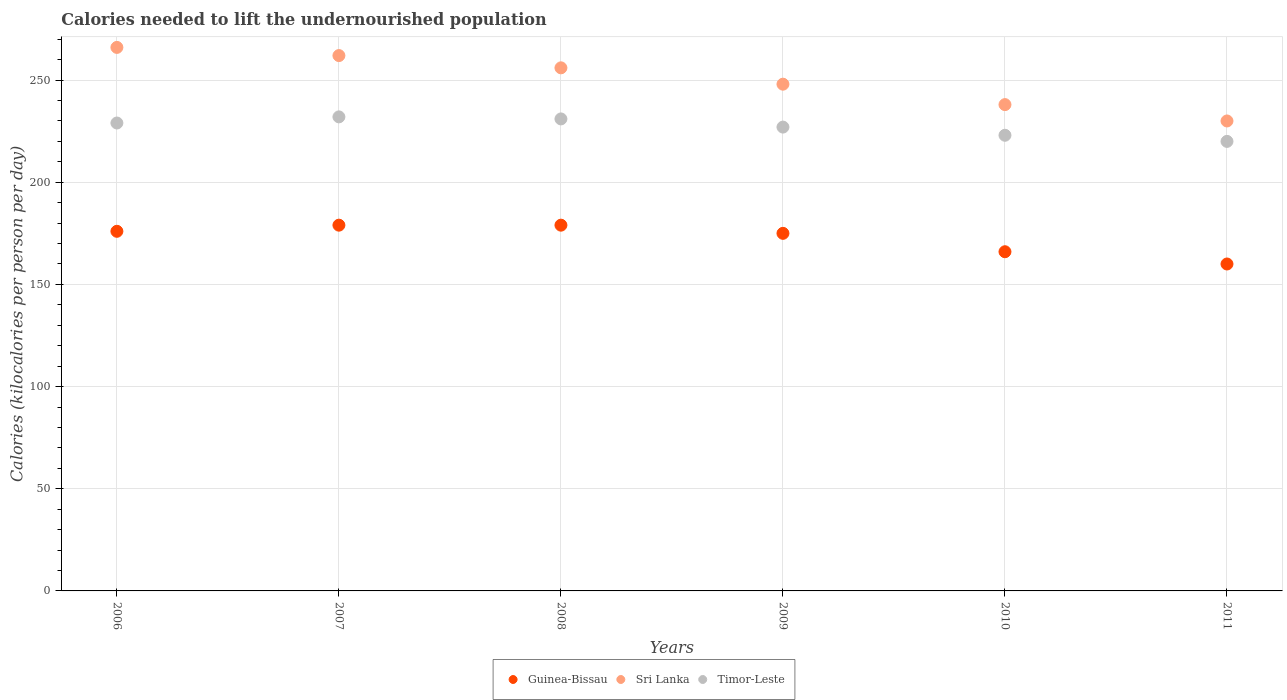How many different coloured dotlines are there?
Ensure brevity in your answer.  3. Is the number of dotlines equal to the number of legend labels?
Provide a succinct answer. Yes. What is the total calories needed to lift the undernourished population in Sri Lanka in 2006?
Provide a short and direct response. 266. Across all years, what is the maximum total calories needed to lift the undernourished population in Timor-Leste?
Your answer should be very brief. 232. Across all years, what is the minimum total calories needed to lift the undernourished population in Sri Lanka?
Give a very brief answer. 230. In which year was the total calories needed to lift the undernourished population in Timor-Leste minimum?
Ensure brevity in your answer.  2011. What is the total total calories needed to lift the undernourished population in Guinea-Bissau in the graph?
Your answer should be very brief. 1035. What is the difference between the total calories needed to lift the undernourished population in Guinea-Bissau in 2007 and the total calories needed to lift the undernourished population in Sri Lanka in 2008?
Your answer should be very brief. -77. What is the average total calories needed to lift the undernourished population in Sri Lanka per year?
Offer a terse response. 250. In the year 2006, what is the difference between the total calories needed to lift the undernourished population in Guinea-Bissau and total calories needed to lift the undernourished population in Timor-Leste?
Give a very brief answer. -53. In how many years, is the total calories needed to lift the undernourished population in Timor-Leste greater than 190 kilocalories?
Offer a terse response. 6. What is the ratio of the total calories needed to lift the undernourished population in Guinea-Bissau in 2008 to that in 2011?
Provide a succinct answer. 1.12. Is the total calories needed to lift the undernourished population in Timor-Leste in 2010 less than that in 2011?
Provide a succinct answer. No. Is the difference between the total calories needed to lift the undernourished population in Guinea-Bissau in 2007 and 2011 greater than the difference between the total calories needed to lift the undernourished population in Timor-Leste in 2007 and 2011?
Offer a very short reply. Yes. What is the difference between the highest and the second highest total calories needed to lift the undernourished population in Guinea-Bissau?
Give a very brief answer. 0. What is the difference between the highest and the lowest total calories needed to lift the undernourished population in Sri Lanka?
Give a very brief answer. 36. In how many years, is the total calories needed to lift the undernourished population in Sri Lanka greater than the average total calories needed to lift the undernourished population in Sri Lanka taken over all years?
Offer a terse response. 3. Is the sum of the total calories needed to lift the undernourished population in Sri Lanka in 2008 and 2010 greater than the maximum total calories needed to lift the undernourished population in Guinea-Bissau across all years?
Offer a very short reply. Yes. Does the total calories needed to lift the undernourished population in Timor-Leste monotonically increase over the years?
Offer a terse response. No. How many dotlines are there?
Your answer should be very brief. 3. How many years are there in the graph?
Ensure brevity in your answer.  6. What is the difference between two consecutive major ticks on the Y-axis?
Your response must be concise. 50. Does the graph contain grids?
Give a very brief answer. Yes. Where does the legend appear in the graph?
Ensure brevity in your answer.  Bottom center. How are the legend labels stacked?
Your response must be concise. Horizontal. What is the title of the graph?
Give a very brief answer. Calories needed to lift the undernourished population. Does "Estonia" appear as one of the legend labels in the graph?
Give a very brief answer. No. What is the label or title of the Y-axis?
Give a very brief answer. Calories (kilocalories per person per day). What is the Calories (kilocalories per person per day) in Guinea-Bissau in 2006?
Provide a succinct answer. 176. What is the Calories (kilocalories per person per day) of Sri Lanka in 2006?
Provide a succinct answer. 266. What is the Calories (kilocalories per person per day) in Timor-Leste in 2006?
Give a very brief answer. 229. What is the Calories (kilocalories per person per day) in Guinea-Bissau in 2007?
Offer a terse response. 179. What is the Calories (kilocalories per person per day) of Sri Lanka in 2007?
Offer a very short reply. 262. What is the Calories (kilocalories per person per day) of Timor-Leste in 2007?
Provide a succinct answer. 232. What is the Calories (kilocalories per person per day) in Guinea-Bissau in 2008?
Offer a very short reply. 179. What is the Calories (kilocalories per person per day) of Sri Lanka in 2008?
Your answer should be compact. 256. What is the Calories (kilocalories per person per day) in Timor-Leste in 2008?
Offer a terse response. 231. What is the Calories (kilocalories per person per day) in Guinea-Bissau in 2009?
Give a very brief answer. 175. What is the Calories (kilocalories per person per day) of Sri Lanka in 2009?
Your answer should be compact. 248. What is the Calories (kilocalories per person per day) in Timor-Leste in 2009?
Provide a short and direct response. 227. What is the Calories (kilocalories per person per day) in Guinea-Bissau in 2010?
Keep it short and to the point. 166. What is the Calories (kilocalories per person per day) in Sri Lanka in 2010?
Keep it short and to the point. 238. What is the Calories (kilocalories per person per day) in Timor-Leste in 2010?
Keep it short and to the point. 223. What is the Calories (kilocalories per person per day) in Guinea-Bissau in 2011?
Provide a short and direct response. 160. What is the Calories (kilocalories per person per day) of Sri Lanka in 2011?
Your answer should be very brief. 230. What is the Calories (kilocalories per person per day) in Timor-Leste in 2011?
Your answer should be compact. 220. Across all years, what is the maximum Calories (kilocalories per person per day) in Guinea-Bissau?
Provide a short and direct response. 179. Across all years, what is the maximum Calories (kilocalories per person per day) of Sri Lanka?
Your answer should be compact. 266. Across all years, what is the maximum Calories (kilocalories per person per day) in Timor-Leste?
Keep it short and to the point. 232. Across all years, what is the minimum Calories (kilocalories per person per day) in Guinea-Bissau?
Ensure brevity in your answer.  160. Across all years, what is the minimum Calories (kilocalories per person per day) in Sri Lanka?
Provide a succinct answer. 230. Across all years, what is the minimum Calories (kilocalories per person per day) of Timor-Leste?
Keep it short and to the point. 220. What is the total Calories (kilocalories per person per day) of Guinea-Bissau in the graph?
Give a very brief answer. 1035. What is the total Calories (kilocalories per person per day) in Sri Lanka in the graph?
Your response must be concise. 1500. What is the total Calories (kilocalories per person per day) of Timor-Leste in the graph?
Offer a terse response. 1362. What is the difference between the Calories (kilocalories per person per day) of Guinea-Bissau in 2006 and that in 2007?
Make the answer very short. -3. What is the difference between the Calories (kilocalories per person per day) in Sri Lanka in 2006 and that in 2009?
Offer a terse response. 18. What is the difference between the Calories (kilocalories per person per day) of Timor-Leste in 2006 and that in 2009?
Provide a succinct answer. 2. What is the difference between the Calories (kilocalories per person per day) of Timor-Leste in 2006 and that in 2010?
Provide a succinct answer. 6. What is the difference between the Calories (kilocalories per person per day) in Guinea-Bissau in 2006 and that in 2011?
Keep it short and to the point. 16. What is the difference between the Calories (kilocalories per person per day) of Guinea-Bissau in 2007 and that in 2008?
Make the answer very short. 0. What is the difference between the Calories (kilocalories per person per day) in Guinea-Bissau in 2007 and that in 2009?
Your answer should be very brief. 4. What is the difference between the Calories (kilocalories per person per day) of Sri Lanka in 2007 and that in 2009?
Offer a very short reply. 14. What is the difference between the Calories (kilocalories per person per day) of Timor-Leste in 2007 and that in 2009?
Your answer should be compact. 5. What is the difference between the Calories (kilocalories per person per day) of Timor-Leste in 2007 and that in 2010?
Give a very brief answer. 9. What is the difference between the Calories (kilocalories per person per day) of Sri Lanka in 2007 and that in 2011?
Give a very brief answer. 32. What is the difference between the Calories (kilocalories per person per day) in Timor-Leste in 2008 and that in 2009?
Provide a succinct answer. 4. What is the difference between the Calories (kilocalories per person per day) of Guinea-Bissau in 2009 and that in 2010?
Your response must be concise. 9. What is the difference between the Calories (kilocalories per person per day) of Timor-Leste in 2009 and that in 2010?
Ensure brevity in your answer.  4. What is the difference between the Calories (kilocalories per person per day) in Guinea-Bissau in 2009 and that in 2011?
Make the answer very short. 15. What is the difference between the Calories (kilocalories per person per day) in Sri Lanka in 2009 and that in 2011?
Your response must be concise. 18. What is the difference between the Calories (kilocalories per person per day) in Timor-Leste in 2009 and that in 2011?
Offer a terse response. 7. What is the difference between the Calories (kilocalories per person per day) in Timor-Leste in 2010 and that in 2011?
Provide a short and direct response. 3. What is the difference between the Calories (kilocalories per person per day) of Guinea-Bissau in 2006 and the Calories (kilocalories per person per day) of Sri Lanka in 2007?
Offer a terse response. -86. What is the difference between the Calories (kilocalories per person per day) in Guinea-Bissau in 2006 and the Calories (kilocalories per person per day) in Timor-Leste in 2007?
Provide a succinct answer. -56. What is the difference between the Calories (kilocalories per person per day) in Sri Lanka in 2006 and the Calories (kilocalories per person per day) in Timor-Leste in 2007?
Give a very brief answer. 34. What is the difference between the Calories (kilocalories per person per day) of Guinea-Bissau in 2006 and the Calories (kilocalories per person per day) of Sri Lanka in 2008?
Your response must be concise. -80. What is the difference between the Calories (kilocalories per person per day) in Guinea-Bissau in 2006 and the Calories (kilocalories per person per day) in Timor-Leste in 2008?
Make the answer very short. -55. What is the difference between the Calories (kilocalories per person per day) in Guinea-Bissau in 2006 and the Calories (kilocalories per person per day) in Sri Lanka in 2009?
Make the answer very short. -72. What is the difference between the Calories (kilocalories per person per day) in Guinea-Bissau in 2006 and the Calories (kilocalories per person per day) in Timor-Leste in 2009?
Keep it short and to the point. -51. What is the difference between the Calories (kilocalories per person per day) in Sri Lanka in 2006 and the Calories (kilocalories per person per day) in Timor-Leste in 2009?
Offer a terse response. 39. What is the difference between the Calories (kilocalories per person per day) of Guinea-Bissau in 2006 and the Calories (kilocalories per person per day) of Sri Lanka in 2010?
Your response must be concise. -62. What is the difference between the Calories (kilocalories per person per day) in Guinea-Bissau in 2006 and the Calories (kilocalories per person per day) in Timor-Leste in 2010?
Keep it short and to the point. -47. What is the difference between the Calories (kilocalories per person per day) of Sri Lanka in 2006 and the Calories (kilocalories per person per day) of Timor-Leste in 2010?
Offer a terse response. 43. What is the difference between the Calories (kilocalories per person per day) in Guinea-Bissau in 2006 and the Calories (kilocalories per person per day) in Sri Lanka in 2011?
Your answer should be very brief. -54. What is the difference between the Calories (kilocalories per person per day) of Guinea-Bissau in 2006 and the Calories (kilocalories per person per day) of Timor-Leste in 2011?
Ensure brevity in your answer.  -44. What is the difference between the Calories (kilocalories per person per day) in Sri Lanka in 2006 and the Calories (kilocalories per person per day) in Timor-Leste in 2011?
Your answer should be very brief. 46. What is the difference between the Calories (kilocalories per person per day) in Guinea-Bissau in 2007 and the Calories (kilocalories per person per day) in Sri Lanka in 2008?
Offer a very short reply. -77. What is the difference between the Calories (kilocalories per person per day) of Guinea-Bissau in 2007 and the Calories (kilocalories per person per day) of Timor-Leste in 2008?
Your response must be concise. -52. What is the difference between the Calories (kilocalories per person per day) of Sri Lanka in 2007 and the Calories (kilocalories per person per day) of Timor-Leste in 2008?
Give a very brief answer. 31. What is the difference between the Calories (kilocalories per person per day) in Guinea-Bissau in 2007 and the Calories (kilocalories per person per day) in Sri Lanka in 2009?
Offer a terse response. -69. What is the difference between the Calories (kilocalories per person per day) of Guinea-Bissau in 2007 and the Calories (kilocalories per person per day) of Timor-Leste in 2009?
Provide a short and direct response. -48. What is the difference between the Calories (kilocalories per person per day) of Guinea-Bissau in 2007 and the Calories (kilocalories per person per day) of Sri Lanka in 2010?
Offer a terse response. -59. What is the difference between the Calories (kilocalories per person per day) in Guinea-Bissau in 2007 and the Calories (kilocalories per person per day) in Timor-Leste in 2010?
Offer a very short reply. -44. What is the difference between the Calories (kilocalories per person per day) of Guinea-Bissau in 2007 and the Calories (kilocalories per person per day) of Sri Lanka in 2011?
Offer a terse response. -51. What is the difference between the Calories (kilocalories per person per day) of Guinea-Bissau in 2007 and the Calories (kilocalories per person per day) of Timor-Leste in 2011?
Keep it short and to the point. -41. What is the difference between the Calories (kilocalories per person per day) in Sri Lanka in 2007 and the Calories (kilocalories per person per day) in Timor-Leste in 2011?
Your response must be concise. 42. What is the difference between the Calories (kilocalories per person per day) in Guinea-Bissau in 2008 and the Calories (kilocalories per person per day) in Sri Lanka in 2009?
Give a very brief answer. -69. What is the difference between the Calories (kilocalories per person per day) in Guinea-Bissau in 2008 and the Calories (kilocalories per person per day) in Timor-Leste in 2009?
Offer a very short reply. -48. What is the difference between the Calories (kilocalories per person per day) in Guinea-Bissau in 2008 and the Calories (kilocalories per person per day) in Sri Lanka in 2010?
Your answer should be compact. -59. What is the difference between the Calories (kilocalories per person per day) in Guinea-Bissau in 2008 and the Calories (kilocalories per person per day) in Timor-Leste in 2010?
Offer a very short reply. -44. What is the difference between the Calories (kilocalories per person per day) in Sri Lanka in 2008 and the Calories (kilocalories per person per day) in Timor-Leste in 2010?
Give a very brief answer. 33. What is the difference between the Calories (kilocalories per person per day) of Guinea-Bissau in 2008 and the Calories (kilocalories per person per day) of Sri Lanka in 2011?
Your answer should be compact. -51. What is the difference between the Calories (kilocalories per person per day) in Guinea-Bissau in 2008 and the Calories (kilocalories per person per day) in Timor-Leste in 2011?
Give a very brief answer. -41. What is the difference between the Calories (kilocalories per person per day) of Guinea-Bissau in 2009 and the Calories (kilocalories per person per day) of Sri Lanka in 2010?
Give a very brief answer. -63. What is the difference between the Calories (kilocalories per person per day) of Guinea-Bissau in 2009 and the Calories (kilocalories per person per day) of Timor-Leste in 2010?
Give a very brief answer. -48. What is the difference between the Calories (kilocalories per person per day) in Guinea-Bissau in 2009 and the Calories (kilocalories per person per day) in Sri Lanka in 2011?
Offer a terse response. -55. What is the difference between the Calories (kilocalories per person per day) in Guinea-Bissau in 2009 and the Calories (kilocalories per person per day) in Timor-Leste in 2011?
Provide a succinct answer. -45. What is the difference between the Calories (kilocalories per person per day) in Guinea-Bissau in 2010 and the Calories (kilocalories per person per day) in Sri Lanka in 2011?
Your answer should be compact. -64. What is the difference between the Calories (kilocalories per person per day) of Guinea-Bissau in 2010 and the Calories (kilocalories per person per day) of Timor-Leste in 2011?
Offer a very short reply. -54. What is the average Calories (kilocalories per person per day) of Guinea-Bissau per year?
Provide a short and direct response. 172.5. What is the average Calories (kilocalories per person per day) in Sri Lanka per year?
Keep it short and to the point. 250. What is the average Calories (kilocalories per person per day) of Timor-Leste per year?
Provide a short and direct response. 227. In the year 2006, what is the difference between the Calories (kilocalories per person per day) of Guinea-Bissau and Calories (kilocalories per person per day) of Sri Lanka?
Keep it short and to the point. -90. In the year 2006, what is the difference between the Calories (kilocalories per person per day) in Guinea-Bissau and Calories (kilocalories per person per day) in Timor-Leste?
Ensure brevity in your answer.  -53. In the year 2006, what is the difference between the Calories (kilocalories per person per day) of Sri Lanka and Calories (kilocalories per person per day) of Timor-Leste?
Provide a succinct answer. 37. In the year 2007, what is the difference between the Calories (kilocalories per person per day) in Guinea-Bissau and Calories (kilocalories per person per day) in Sri Lanka?
Provide a succinct answer. -83. In the year 2007, what is the difference between the Calories (kilocalories per person per day) of Guinea-Bissau and Calories (kilocalories per person per day) of Timor-Leste?
Offer a very short reply. -53. In the year 2008, what is the difference between the Calories (kilocalories per person per day) of Guinea-Bissau and Calories (kilocalories per person per day) of Sri Lanka?
Make the answer very short. -77. In the year 2008, what is the difference between the Calories (kilocalories per person per day) in Guinea-Bissau and Calories (kilocalories per person per day) in Timor-Leste?
Ensure brevity in your answer.  -52. In the year 2009, what is the difference between the Calories (kilocalories per person per day) in Guinea-Bissau and Calories (kilocalories per person per day) in Sri Lanka?
Keep it short and to the point. -73. In the year 2009, what is the difference between the Calories (kilocalories per person per day) in Guinea-Bissau and Calories (kilocalories per person per day) in Timor-Leste?
Provide a succinct answer. -52. In the year 2010, what is the difference between the Calories (kilocalories per person per day) of Guinea-Bissau and Calories (kilocalories per person per day) of Sri Lanka?
Your answer should be very brief. -72. In the year 2010, what is the difference between the Calories (kilocalories per person per day) in Guinea-Bissau and Calories (kilocalories per person per day) in Timor-Leste?
Give a very brief answer. -57. In the year 2011, what is the difference between the Calories (kilocalories per person per day) in Guinea-Bissau and Calories (kilocalories per person per day) in Sri Lanka?
Your response must be concise. -70. In the year 2011, what is the difference between the Calories (kilocalories per person per day) of Guinea-Bissau and Calories (kilocalories per person per day) of Timor-Leste?
Make the answer very short. -60. In the year 2011, what is the difference between the Calories (kilocalories per person per day) of Sri Lanka and Calories (kilocalories per person per day) of Timor-Leste?
Offer a terse response. 10. What is the ratio of the Calories (kilocalories per person per day) of Guinea-Bissau in 2006 to that in 2007?
Your answer should be very brief. 0.98. What is the ratio of the Calories (kilocalories per person per day) in Sri Lanka in 2006 to that in 2007?
Make the answer very short. 1.02. What is the ratio of the Calories (kilocalories per person per day) of Timor-Leste in 2006 to that in 2007?
Make the answer very short. 0.99. What is the ratio of the Calories (kilocalories per person per day) of Guinea-Bissau in 2006 to that in 2008?
Give a very brief answer. 0.98. What is the ratio of the Calories (kilocalories per person per day) of Sri Lanka in 2006 to that in 2008?
Your response must be concise. 1.04. What is the ratio of the Calories (kilocalories per person per day) in Timor-Leste in 2006 to that in 2008?
Make the answer very short. 0.99. What is the ratio of the Calories (kilocalories per person per day) in Sri Lanka in 2006 to that in 2009?
Your response must be concise. 1.07. What is the ratio of the Calories (kilocalories per person per day) of Timor-Leste in 2006 to that in 2009?
Offer a very short reply. 1.01. What is the ratio of the Calories (kilocalories per person per day) in Guinea-Bissau in 2006 to that in 2010?
Ensure brevity in your answer.  1.06. What is the ratio of the Calories (kilocalories per person per day) of Sri Lanka in 2006 to that in 2010?
Your answer should be very brief. 1.12. What is the ratio of the Calories (kilocalories per person per day) of Timor-Leste in 2006 to that in 2010?
Keep it short and to the point. 1.03. What is the ratio of the Calories (kilocalories per person per day) in Guinea-Bissau in 2006 to that in 2011?
Your answer should be compact. 1.1. What is the ratio of the Calories (kilocalories per person per day) of Sri Lanka in 2006 to that in 2011?
Your answer should be compact. 1.16. What is the ratio of the Calories (kilocalories per person per day) in Timor-Leste in 2006 to that in 2011?
Provide a succinct answer. 1.04. What is the ratio of the Calories (kilocalories per person per day) of Guinea-Bissau in 2007 to that in 2008?
Your response must be concise. 1. What is the ratio of the Calories (kilocalories per person per day) of Sri Lanka in 2007 to that in 2008?
Your answer should be very brief. 1.02. What is the ratio of the Calories (kilocalories per person per day) of Guinea-Bissau in 2007 to that in 2009?
Provide a succinct answer. 1.02. What is the ratio of the Calories (kilocalories per person per day) in Sri Lanka in 2007 to that in 2009?
Your answer should be very brief. 1.06. What is the ratio of the Calories (kilocalories per person per day) in Timor-Leste in 2007 to that in 2009?
Offer a terse response. 1.02. What is the ratio of the Calories (kilocalories per person per day) in Guinea-Bissau in 2007 to that in 2010?
Your response must be concise. 1.08. What is the ratio of the Calories (kilocalories per person per day) in Sri Lanka in 2007 to that in 2010?
Offer a terse response. 1.1. What is the ratio of the Calories (kilocalories per person per day) in Timor-Leste in 2007 to that in 2010?
Your response must be concise. 1.04. What is the ratio of the Calories (kilocalories per person per day) of Guinea-Bissau in 2007 to that in 2011?
Provide a short and direct response. 1.12. What is the ratio of the Calories (kilocalories per person per day) in Sri Lanka in 2007 to that in 2011?
Your answer should be compact. 1.14. What is the ratio of the Calories (kilocalories per person per day) of Timor-Leste in 2007 to that in 2011?
Your response must be concise. 1.05. What is the ratio of the Calories (kilocalories per person per day) of Guinea-Bissau in 2008 to that in 2009?
Make the answer very short. 1.02. What is the ratio of the Calories (kilocalories per person per day) in Sri Lanka in 2008 to that in 2009?
Offer a very short reply. 1.03. What is the ratio of the Calories (kilocalories per person per day) of Timor-Leste in 2008 to that in 2009?
Provide a short and direct response. 1.02. What is the ratio of the Calories (kilocalories per person per day) in Guinea-Bissau in 2008 to that in 2010?
Provide a short and direct response. 1.08. What is the ratio of the Calories (kilocalories per person per day) of Sri Lanka in 2008 to that in 2010?
Provide a short and direct response. 1.08. What is the ratio of the Calories (kilocalories per person per day) of Timor-Leste in 2008 to that in 2010?
Give a very brief answer. 1.04. What is the ratio of the Calories (kilocalories per person per day) in Guinea-Bissau in 2008 to that in 2011?
Give a very brief answer. 1.12. What is the ratio of the Calories (kilocalories per person per day) in Sri Lanka in 2008 to that in 2011?
Provide a succinct answer. 1.11. What is the ratio of the Calories (kilocalories per person per day) in Guinea-Bissau in 2009 to that in 2010?
Offer a terse response. 1.05. What is the ratio of the Calories (kilocalories per person per day) of Sri Lanka in 2009 to that in 2010?
Ensure brevity in your answer.  1.04. What is the ratio of the Calories (kilocalories per person per day) of Timor-Leste in 2009 to that in 2010?
Ensure brevity in your answer.  1.02. What is the ratio of the Calories (kilocalories per person per day) of Guinea-Bissau in 2009 to that in 2011?
Offer a very short reply. 1.09. What is the ratio of the Calories (kilocalories per person per day) of Sri Lanka in 2009 to that in 2011?
Your response must be concise. 1.08. What is the ratio of the Calories (kilocalories per person per day) in Timor-Leste in 2009 to that in 2011?
Your answer should be very brief. 1.03. What is the ratio of the Calories (kilocalories per person per day) in Guinea-Bissau in 2010 to that in 2011?
Provide a short and direct response. 1.04. What is the ratio of the Calories (kilocalories per person per day) in Sri Lanka in 2010 to that in 2011?
Give a very brief answer. 1.03. What is the ratio of the Calories (kilocalories per person per day) of Timor-Leste in 2010 to that in 2011?
Your answer should be compact. 1.01. What is the difference between the highest and the second highest Calories (kilocalories per person per day) in Sri Lanka?
Your answer should be compact. 4. What is the difference between the highest and the lowest Calories (kilocalories per person per day) of Sri Lanka?
Your answer should be very brief. 36. What is the difference between the highest and the lowest Calories (kilocalories per person per day) in Timor-Leste?
Give a very brief answer. 12. 